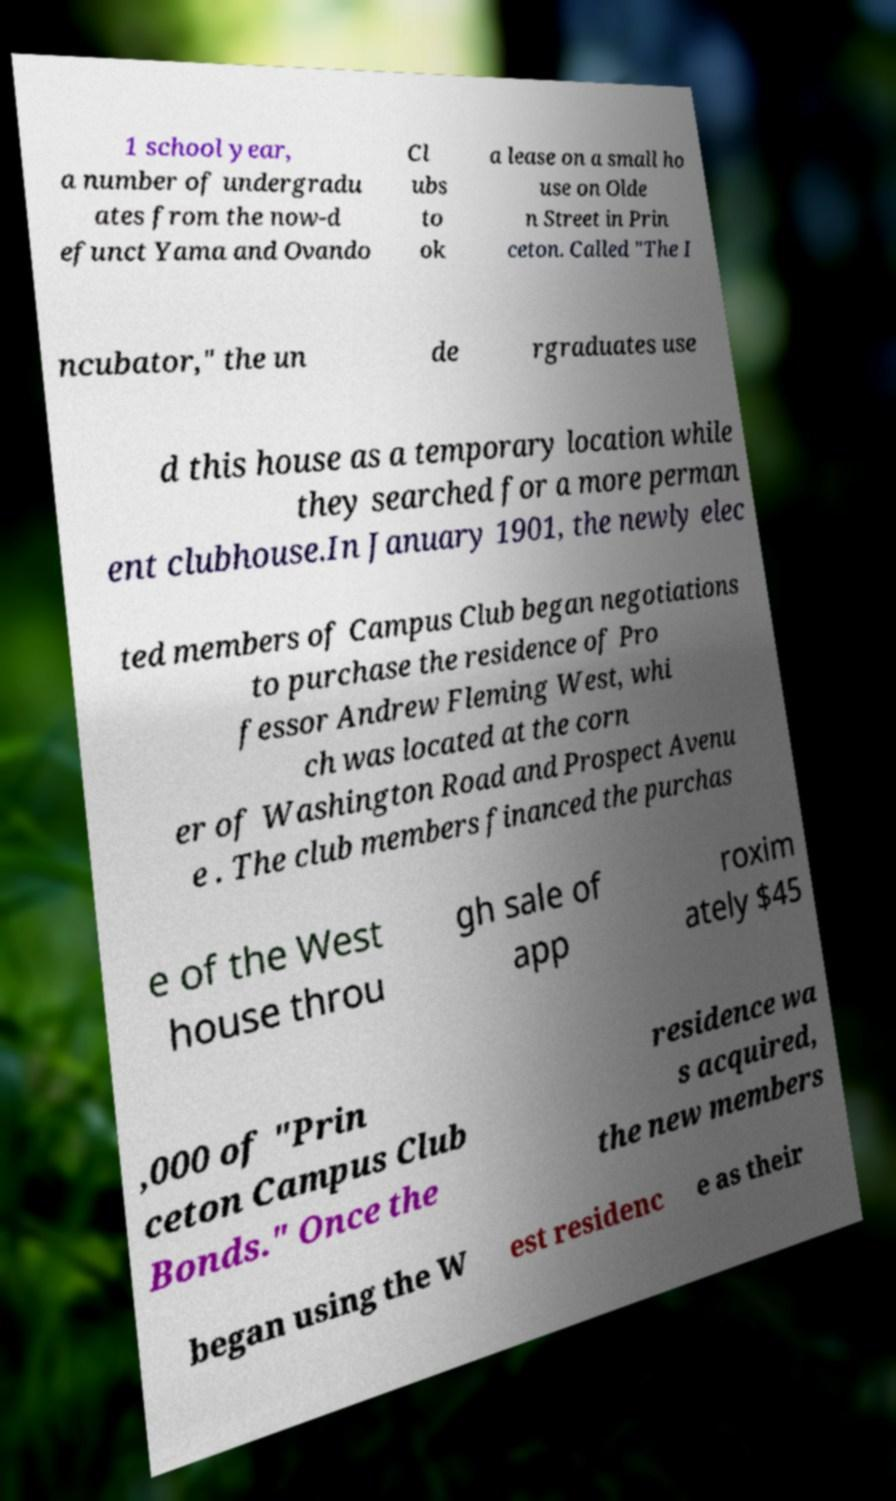Please identify and transcribe the text found in this image. 1 school year, a number of undergradu ates from the now-d efunct Yama and Ovando Cl ubs to ok a lease on a small ho use on Olde n Street in Prin ceton. Called "The I ncubator," the un de rgraduates use d this house as a temporary location while they searched for a more perman ent clubhouse.In January 1901, the newly elec ted members of Campus Club began negotiations to purchase the residence of Pro fessor Andrew Fleming West, whi ch was located at the corn er of Washington Road and Prospect Avenu e . The club members financed the purchas e of the West house throu gh sale of app roxim ately $45 ,000 of "Prin ceton Campus Club Bonds." Once the residence wa s acquired, the new members began using the W est residenc e as their 